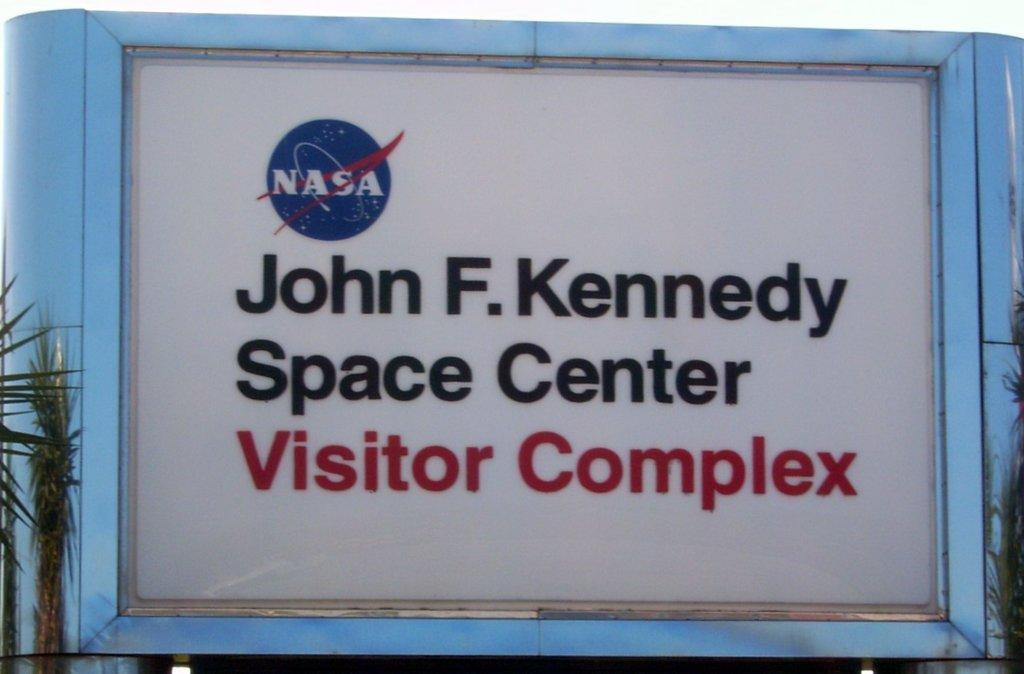<image>
Relay a brief, clear account of the picture shown. Sign for a buliding which says "Visitor Complex" in red. 